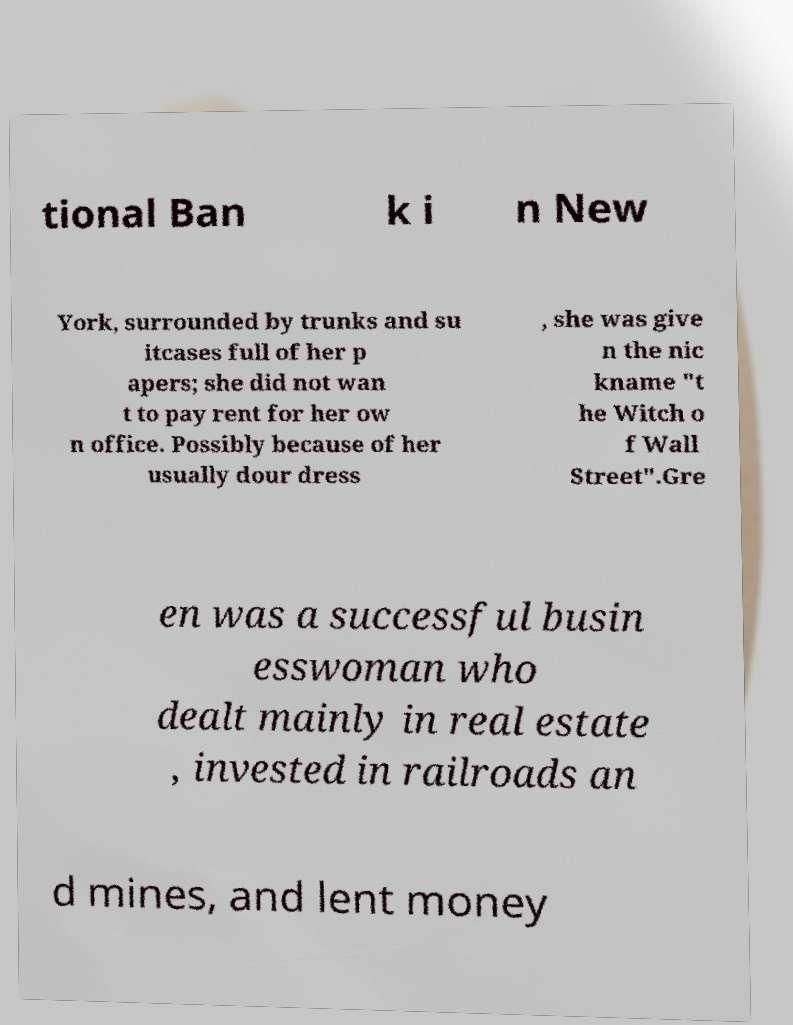For documentation purposes, I need the text within this image transcribed. Could you provide that? tional Ban k i n New York, surrounded by trunks and su itcases full of her p apers; she did not wan t to pay rent for her ow n office. Possibly because of her usually dour dress , she was give n the nic kname "t he Witch o f Wall Street".Gre en was a successful busin esswoman who dealt mainly in real estate , invested in railroads an d mines, and lent money 